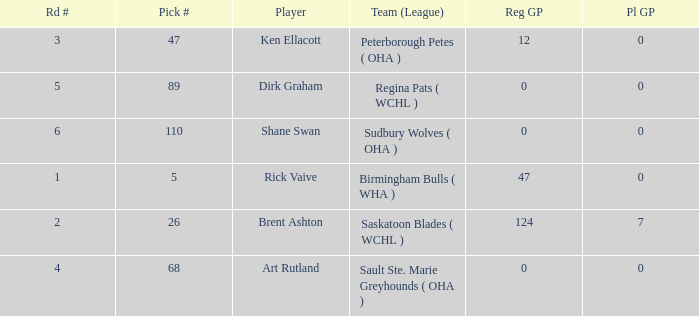How many reg GP for rick vaive in round 1? None. 